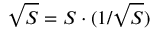<formula> <loc_0><loc_0><loc_500><loc_500>{ \sqrt { S } } = S \cdot ( 1 / { \sqrt { S } } )</formula> 